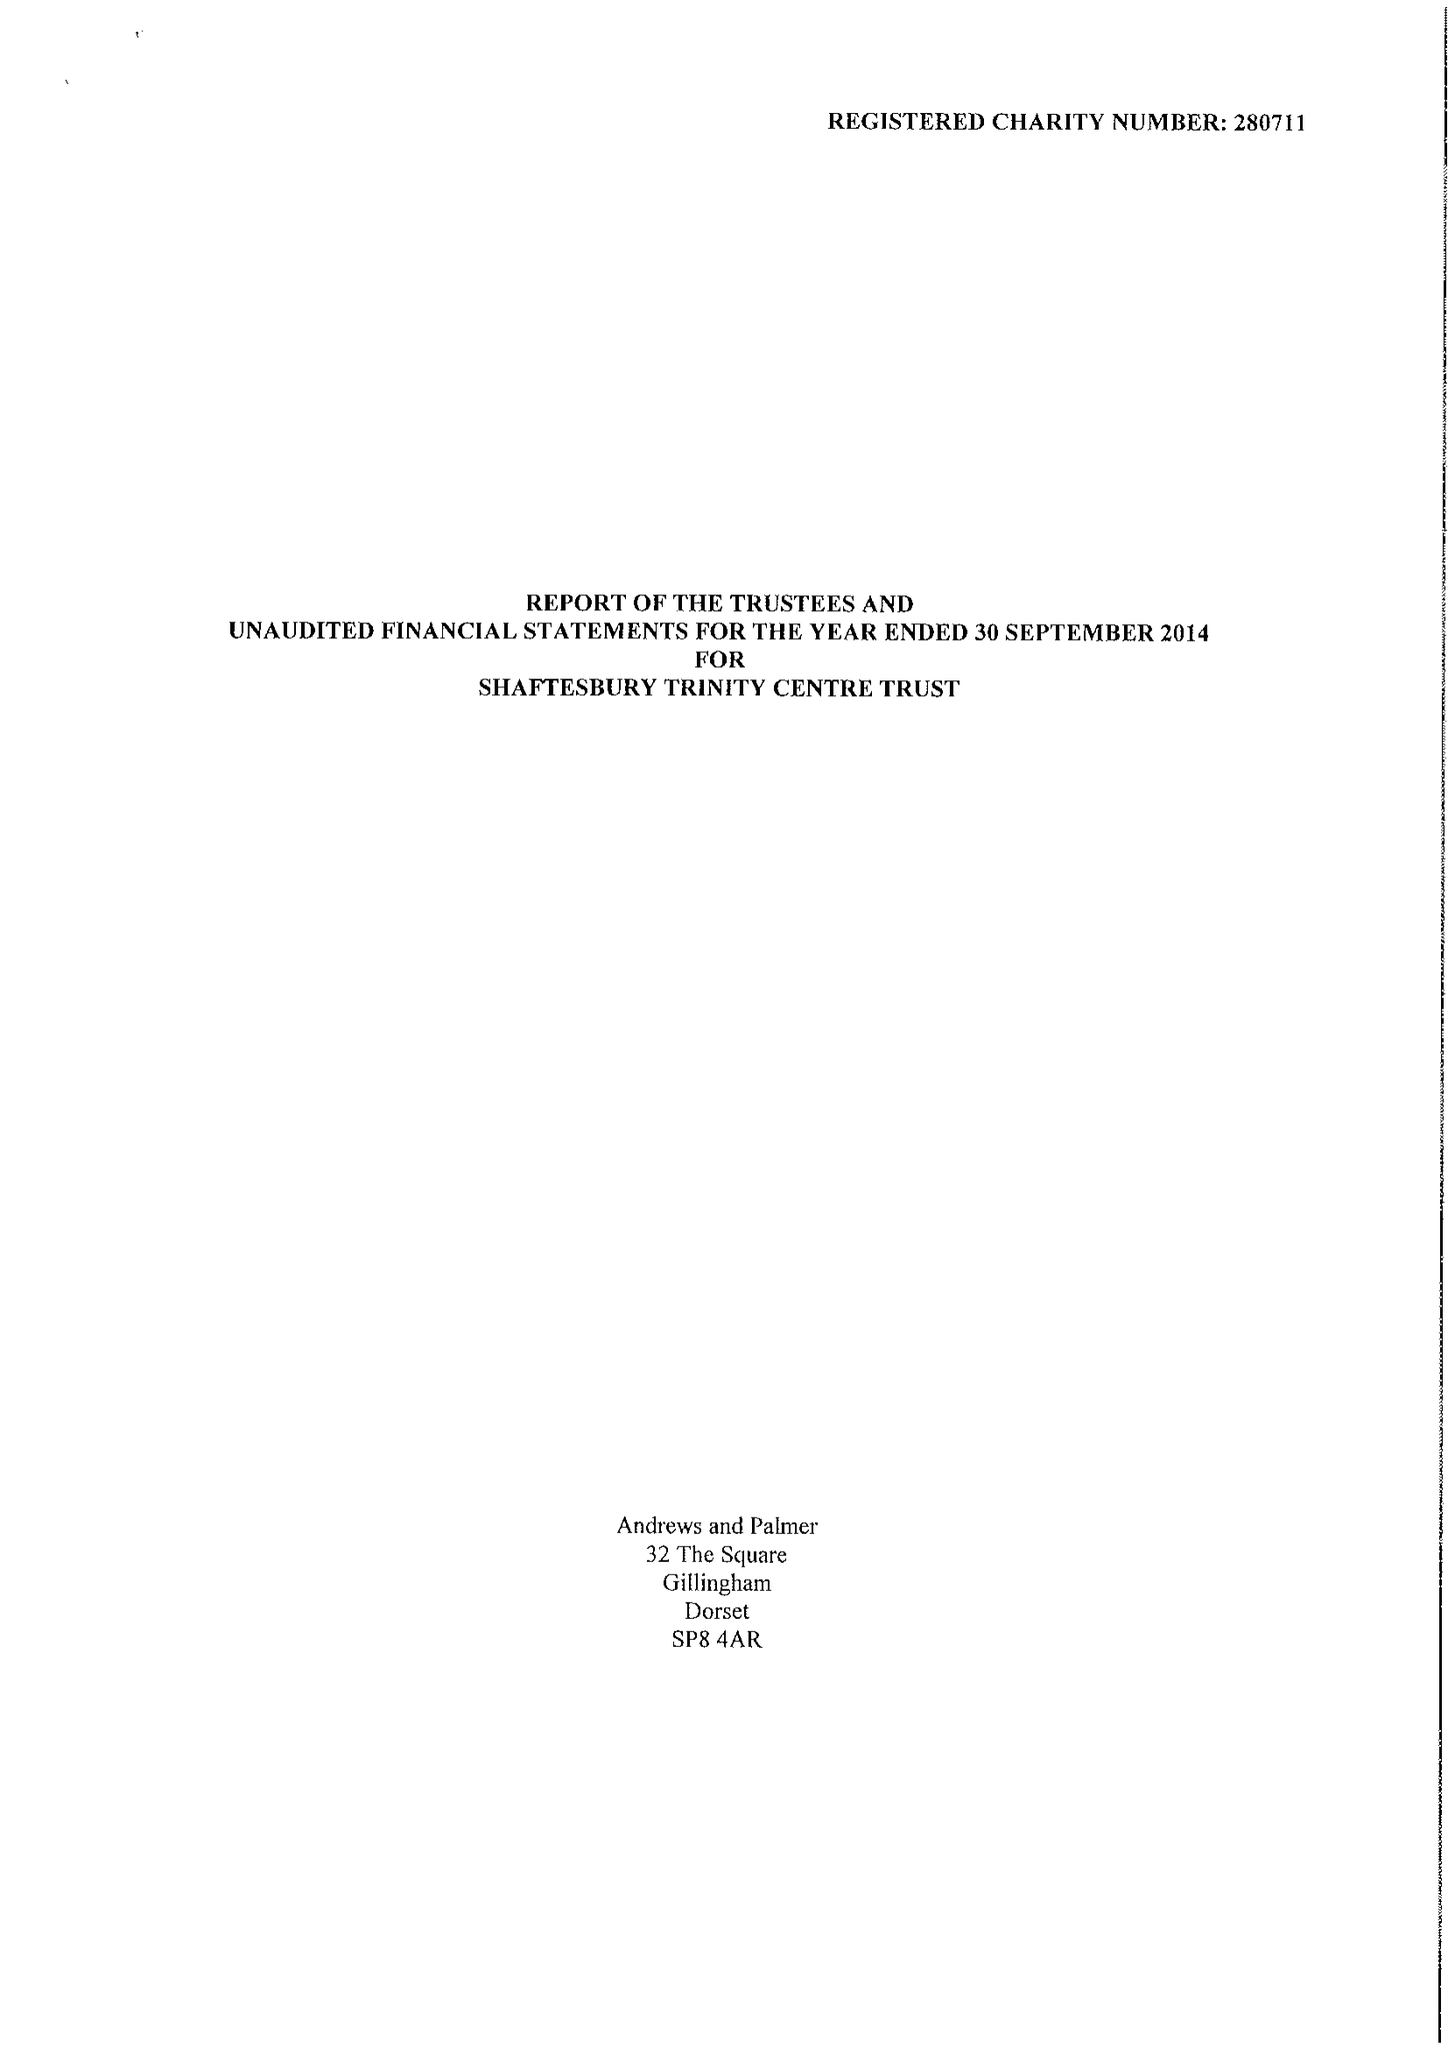What is the value for the income_annually_in_british_pounds?
Answer the question using a single word or phrase. 50139.00 